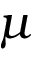Convert formula to latex. <formula><loc_0><loc_0><loc_500><loc_500>\mu</formula> 